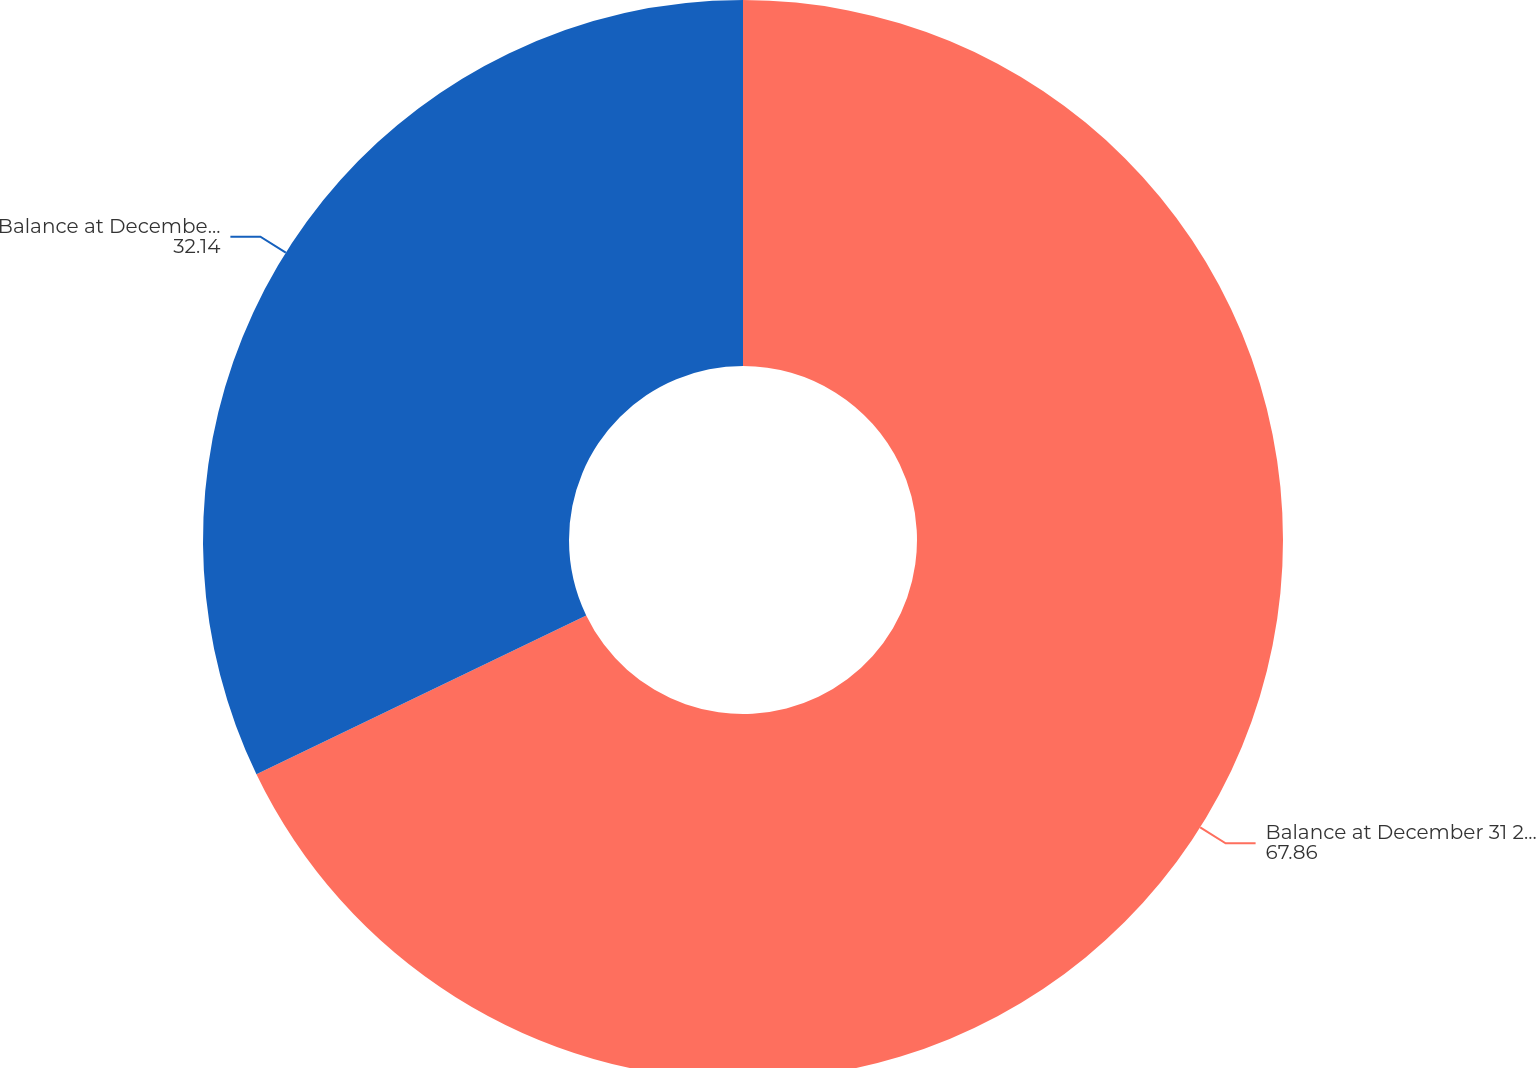<chart> <loc_0><loc_0><loc_500><loc_500><pie_chart><fcel>Balance at December 31 2015<fcel>Balance at December 31 2016<nl><fcel>67.86%<fcel>32.14%<nl></chart> 